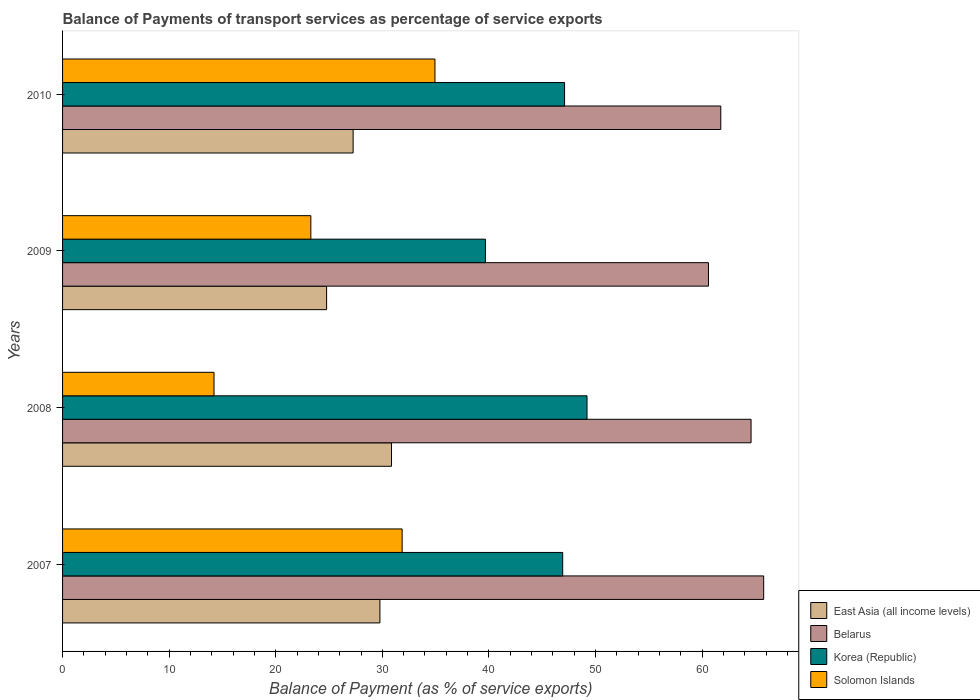How many different coloured bars are there?
Offer a terse response. 4. Are the number of bars per tick equal to the number of legend labels?
Offer a terse response. Yes. Are the number of bars on each tick of the Y-axis equal?
Ensure brevity in your answer.  Yes. How many bars are there on the 2nd tick from the top?
Keep it short and to the point. 4. In how many cases, is the number of bars for a given year not equal to the number of legend labels?
Keep it short and to the point. 0. What is the balance of payments of transport services in East Asia (all income levels) in 2009?
Your answer should be very brief. 24.77. Across all years, what is the maximum balance of payments of transport services in Solomon Islands?
Offer a very short reply. 34.94. Across all years, what is the minimum balance of payments of transport services in Solomon Islands?
Offer a terse response. 14.21. In which year was the balance of payments of transport services in Korea (Republic) maximum?
Keep it short and to the point. 2008. In which year was the balance of payments of transport services in East Asia (all income levels) minimum?
Provide a succinct answer. 2009. What is the total balance of payments of transport services in Korea (Republic) in the graph?
Offer a terse response. 182.9. What is the difference between the balance of payments of transport services in Korea (Republic) in 2007 and that in 2009?
Make the answer very short. 7.25. What is the difference between the balance of payments of transport services in Solomon Islands in 2010 and the balance of payments of transport services in Belarus in 2007?
Offer a terse response. -30.84. What is the average balance of payments of transport services in East Asia (all income levels) per year?
Ensure brevity in your answer.  28.17. In the year 2010, what is the difference between the balance of payments of transport services in East Asia (all income levels) and balance of payments of transport services in Belarus?
Offer a very short reply. -34.49. In how many years, is the balance of payments of transport services in East Asia (all income levels) greater than 16 %?
Ensure brevity in your answer.  4. What is the ratio of the balance of payments of transport services in Korea (Republic) in 2007 to that in 2008?
Provide a succinct answer. 0.95. Is the balance of payments of transport services in Belarus in 2007 less than that in 2009?
Offer a very short reply. No. What is the difference between the highest and the second highest balance of payments of transport services in Belarus?
Provide a short and direct response. 1.18. What is the difference between the highest and the lowest balance of payments of transport services in Belarus?
Make the answer very short. 5.18. In how many years, is the balance of payments of transport services in East Asia (all income levels) greater than the average balance of payments of transport services in East Asia (all income levels) taken over all years?
Give a very brief answer. 2. Is the sum of the balance of payments of transport services in Solomon Islands in 2007 and 2010 greater than the maximum balance of payments of transport services in Korea (Republic) across all years?
Your response must be concise. Yes. Is it the case that in every year, the sum of the balance of payments of transport services in Korea (Republic) and balance of payments of transport services in East Asia (all income levels) is greater than the sum of balance of payments of transport services in Belarus and balance of payments of transport services in Solomon Islands?
Your answer should be very brief. No. What does the 4th bar from the top in 2009 represents?
Ensure brevity in your answer.  East Asia (all income levels). What does the 4th bar from the bottom in 2009 represents?
Your answer should be very brief. Solomon Islands. Is it the case that in every year, the sum of the balance of payments of transport services in Korea (Republic) and balance of payments of transport services in Solomon Islands is greater than the balance of payments of transport services in East Asia (all income levels)?
Ensure brevity in your answer.  Yes. How many bars are there?
Your response must be concise. 16. Are the values on the major ticks of X-axis written in scientific E-notation?
Your answer should be compact. No. Does the graph contain grids?
Ensure brevity in your answer.  No. Where does the legend appear in the graph?
Provide a short and direct response. Bottom right. How are the legend labels stacked?
Provide a short and direct response. Vertical. What is the title of the graph?
Ensure brevity in your answer.  Balance of Payments of transport services as percentage of service exports. Does "Luxembourg" appear as one of the legend labels in the graph?
Provide a short and direct response. No. What is the label or title of the X-axis?
Keep it short and to the point. Balance of Payment (as % of service exports). What is the label or title of the Y-axis?
Offer a terse response. Years. What is the Balance of Payment (as % of service exports) of East Asia (all income levels) in 2007?
Keep it short and to the point. 29.78. What is the Balance of Payment (as % of service exports) of Belarus in 2007?
Provide a succinct answer. 65.78. What is the Balance of Payment (as % of service exports) in Korea (Republic) in 2007?
Your response must be concise. 46.92. What is the Balance of Payment (as % of service exports) in Solomon Islands in 2007?
Offer a terse response. 31.86. What is the Balance of Payment (as % of service exports) of East Asia (all income levels) in 2008?
Provide a succinct answer. 30.86. What is the Balance of Payment (as % of service exports) of Belarus in 2008?
Provide a succinct answer. 64.6. What is the Balance of Payment (as % of service exports) in Korea (Republic) in 2008?
Offer a terse response. 49.21. What is the Balance of Payment (as % of service exports) of Solomon Islands in 2008?
Provide a succinct answer. 14.21. What is the Balance of Payment (as % of service exports) of East Asia (all income levels) in 2009?
Make the answer very short. 24.77. What is the Balance of Payment (as % of service exports) in Belarus in 2009?
Keep it short and to the point. 60.6. What is the Balance of Payment (as % of service exports) of Korea (Republic) in 2009?
Your response must be concise. 39.67. What is the Balance of Payment (as % of service exports) of Solomon Islands in 2009?
Provide a succinct answer. 23.29. What is the Balance of Payment (as % of service exports) in East Asia (all income levels) in 2010?
Make the answer very short. 27.26. What is the Balance of Payment (as % of service exports) of Belarus in 2010?
Offer a very short reply. 61.75. What is the Balance of Payment (as % of service exports) in Korea (Republic) in 2010?
Your response must be concise. 47.1. What is the Balance of Payment (as % of service exports) in Solomon Islands in 2010?
Make the answer very short. 34.94. Across all years, what is the maximum Balance of Payment (as % of service exports) in East Asia (all income levels)?
Offer a terse response. 30.86. Across all years, what is the maximum Balance of Payment (as % of service exports) in Belarus?
Provide a succinct answer. 65.78. Across all years, what is the maximum Balance of Payment (as % of service exports) in Korea (Republic)?
Your answer should be very brief. 49.21. Across all years, what is the maximum Balance of Payment (as % of service exports) of Solomon Islands?
Offer a very short reply. 34.94. Across all years, what is the minimum Balance of Payment (as % of service exports) of East Asia (all income levels)?
Make the answer very short. 24.77. Across all years, what is the minimum Balance of Payment (as % of service exports) of Belarus?
Make the answer very short. 60.6. Across all years, what is the minimum Balance of Payment (as % of service exports) of Korea (Republic)?
Provide a succinct answer. 39.67. Across all years, what is the minimum Balance of Payment (as % of service exports) in Solomon Islands?
Your response must be concise. 14.21. What is the total Balance of Payment (as % of service exports) of East Asia (all income levels) in the graph?
Offer a very short reply. 112.67. What is the total Balance of Payment (as % of service exports) of Belarus in the graph?
Make the answer very short. 252.73. What is the total Balance of Payment (as % of service exports) in Korea (Republic) in the graph?
Ensure brevity in your answer.  182.9. What is the total Balance of Payment (as % of service exports) in Solomon Islands in the graph?
Give a very brief answer. 104.3. What is the difference between the Balance of Payment (as % of service exports) of East Asia (all income levels) in 2007 and that in 2008?
Give a very brief answer. -1.09. What is the difference between the Balance of Payment (as % of service exports) in Belarus in 2007 and that in 2008?
Offer a terse response. 1.18. What is the difference between the Balance of Payment (as % of service exports) in Korea (Republic) in 2007 and that in 2008?
Offer a very short reply. -2.28. What is the difference between the Balance of Payment (as % of service exports) in Solomon Islands in 2007 and that in 2008?
Keep it short and to the point. 17.65. What is the difference between the Balance of Payment (as % of service exports) in East Asia (all income levels) in 2007 and that in 2009?
Offer a very short reply. 5. What is the difference between the Balance of Payment (as % of service exports) of Belarus in 2007 and that in 2009?
Offer a very short reply. 5.18. What is the difference between the Balance of Payment (as % of service exports) in Korea (Republic) in 2007 and that in 2009?
Your answer should be very brief. 7.25. What is the difference between the Balance of Payment (as % of service exports) in Solomon Islands in 2007 and that in 2009?
Your answer should be very brief. 8.57. What is the difference between the Balance of Payment (as % of service exports) of East Asia (all income levels) in 2007 and that in 2010?
Give a very brief answer. 2.51. What is the difference between the Balance of Payment (as % of service exports) of Belarus in 2007 and that in 2010?
Provide a short and direct response. 4.03. What is the difference between the Balance of Payment (as % of service exports) of Korea (Republic) in 2007 and that in 2010?
Give a very brief answer. -0.18. What is the difference between the Balance of Payment (as % of service exports) of Solomon Islands in 2007 and that in 2010?
Your response must be concise. -3.08. What is the difference between the Balance of Payment (as % of service exports) of East Asia (all income levels) in 2008 and that in 2009?
Your response must be concise. 6.09. What is the difference between the Balance of Payment (as % of service exports) in Belarus in 2008 and that in 2009?
Keep it short and to the point. 4. What is the difference between the Balance of Payment (as % of service exports) in Korea (Republic) in 2008 and that in 2009?
Provide a short and direct response. 9.53. What is the difference between the Balance of Payment (as % of service exports) of Solomon Islands in 2008 and that in 2009?
Ensure brevity in your answer.  -9.08. What is the difference between the Balance of Payment (as % of service exports) in East Asia (all income levels) in 2008 and that in 2010?
Give a very brief answer. 3.6. What is the difference between the Balance of Payment (as % of service exports) of Belarus in 2008 and that in 2010?
Give a very brief answer. 2.84. What is the difference between the Balance of Payment (as % of service exports) of Korea (Republic) in 2008 and that in 2010?
Provide a short and direct response. 2.11. What is the difference between the Balance of Payment (as % of service exports) of Solomon Islands in 2008 and that in 2010?
Provide a succinct answer. -20.73. What is the difference between the Balance of Payment (as % of service exports) of East Asia (all income levels) in 2009 and that in 2010?
Provide a succinct answer. -2.49. What is the difference between the Balance of Payment (as % of service exports) in Belarus in 2009 and that in 2010?
Your answer should be compact. -1.16. What is the difference between the Balance of Payment (as % of service exports) in Korea (Republic) in 2009 and that in 2010?
Provide a short and direct response. -7.43. What is the difference between the Balance of Payment (as % of service exports) of Solomon Islands in 2009 and that in 2010?
Ensure brevity in your answer.  -11.64. What is the difference between the Balance of Payment (as % of service exports) in East Asia (all income levels) in 2007 and the Balance of Payment (as % of service exports) in Belarus in 2008?
Keep it short and to the point. -34.82. What is the difference between the Balance of Payment (as % of service exports) of East Asia (all income levels) in 2007 and the Balance of Payment (as % of service exports) of Korea (Republic) in 2008?
Provide a succinct answer. -19.43. What is the difference between the Balance of Payment (as % of service exports) of East Asia (all income levels) in 2007 and the Balance of Payment (as % of service exports) of Solomon Islands in 2008?
Give a very brief answer. 15.56. What is the difference between the Balance of Payment (as % of service exports) in Belarus in 2007 and the Balance of Payment (as % of service exports) in Korea (Republic) in 2008?
Give a very brief answer. 16.57. What is the difference between the Balance of Payment (as % of service exports) in Belarus in 2007 and the Balance of Payment (as % of service exports) in Solomon Islands in 2008?
Keep it short and to the point. 51.57. What is the difference between the Balance of Payment (as % of service exports) of Korea (Republic) in 2007 and the Balance of Payment (as % of service exports) of Solomon Islands in 2008?
Provide a short and direct response. 32.71. What is the difference between the Balance of Payment (as % of service exports) in East Asia (all income levels) in 2007 and the Balance of Payment (as % of service exports) in Belarus in 2009?
Provide a succinct answer. -30.82. What is the difference between the Balance of Payment (as % of service exports) of East Asia (all income levels) in 2007 and the Balance of Payment (as % of service exports) of Korea (Republic) in 2009?
Keep it short and to the point. -9.9. What is the difference between the Balance of Payment (as % of service exports) of East Asia (all income levels) in 2007 and the Balance of Payment (as % of service exports) of Solomon Islands in 2009?
Your response must be concise. 6.48. What is the difference between the Balance of Payment (as % of service exports) in Belarus in 2007 and the Balance of Payment (as % of service exports) in Korea (Republic) in 2009?
Your answer should be compact. 26.11. What is the difference between the Balance of Payment (as % of service exports) in Belarus in 2007 and the Balance of Payment (as % of service exports) in Solomon Islands in 2009?
Make the answer very short. 42.49. What is the difference between the Balance of Payment (as % of service exports) of Korea (Republic) in 2007 and the Balance of Payment (as % of service exports) of Solomon Islands in 2009?
Your answer should be very brief. 23.63. What is the difference between the Balance of Payment (as % of service exports) in East Asia (all income levels) in 2007 and the Balance of Payment (as % of service exports) in Belarus in 2010?
Offer a terse response. -31.98. What is the difference between the Balance of Payment (as % of service exports) in East Asia (all income levels) in 2007 and the Balance of Payment (as % of service exports) in Korea (Republic) in 2010?
Provide a succinct answer. -17.32. What is the difference between the Balance of Payment (as % of service exports) of East Asia (all income levels) in 2007 and the Balance of Payment (as % of service exports) of Solomon Islands in 2010?
Make the answer very short. -5.16. What is the difference between the Balance of Payment (as % of service exports) in Belarus in 2007 and the Balance of Payment (as % of service exports) in Korea (Republic) in 2010?
Provide a succinct answer. 18.68. What is the difference between the Balance of Payment (as % of service exports) in Belarus in 2007 and the Balance of Payment (as % of service exports) in Solomon Islands in 2010?
Offer a very short reply. 30.84. What is the difference between the Balance of Payment (as % of service exports) in Korea (Republic) in 2007 and the Balance of Payment (as % of service exports) in Solomon Islands in 2010?
Give a very brief answer. 11.99. What is the difference between the Balance of Payment (as % of service exports) of East Asia (all income levels) in 2008 and the Balance of Payment (as % of service exports) of Belarus in 2009?
Provide a succinct answer. -29.74. What is the difference between the Balance of Payment (as % of service exports) in East Asia (all income levels) in 2008 and the Balance of Payment (as % of service exports) in Korea (Republic) in 2009?
Offer a very short reply. -8.81. What is the difference between the Balance of Payment (as % of service exports) in East Asia (all income levels) in 2008 and the Balance of Payment (as % of service exports) in Solomon Islands in 2009?
Make the answer very short. 7.57. What is the difference between the Balance of Payment (as % of service exports) in Belarus in 2008 and the Balance of Payment (as % of service exports) in Korea (Republic) in 2009?
Give a very brief answer. 24.92. What is the difference between the Balance of Payment (as % of service exports) of Belarus in 2008 and the Balance of Payment (as % of service exports) of Solomon Islands in 2009?
Make the answer very short. 41.3. What is the difference between the Balance of Payment (as % of service exports) of Korea (Republic) in 2008 and the Balance of Payment (as % of service exports) of Solomon Islands in 2009?
Your response must be concise. 25.91. What is the difference between the Balance of Payment (as % of service exports) in East Asia (all income levels) in 2008 and the Balance of Payment (as % of service exports) in Belarus in 2010?
Your response must be concise. -30.89. What is the difference between the Balance of Payment (as % of service exports) of East Asia (all income levels) in 2008 and the Balance of Payment (as % of service exports) of Korea (Republic) in 2010?
Your answer should be compact. -16.24. What is the difference between the Balance of Payment (as % of service exports) in East Asia (all income levels) in 2008 and the Balance of Payment (as % of service exports) in Solomon Islands in 2010?
Ensure brevity in your answer.  -4.08. What is the difference between the Balance of Payment (as % of service exports) of Belarus in 2008 and the Balance of Payment (as % of service exports) of Korea (Republic) in 2010?
Keep it short and to the point. 17.5. What is the difference between the Balance of Payment (as % of service exports) of Belarus in 2008 and the Balance of Payment (as % of service exports) of Solomon Islands in 2010?
Your answer should be compact. 29.66. What is the difference between the Balance of Payment (as % of service exports) in Korea (Republic) in 2008 and the Balance of Payment (as % of service exports) in Solomon Islands in 2010?
Offer a very short reply. 14.27. What is the difference between the Balance of Payment (as % of service exports) in East Asia (all income levels) in 2009 and the Balance of Payment (as % of service exports) in Belarus in 2010?
Provide a short and direct response. -36.98. What is the difference between the Balance of Payment (as % of service exports) in East Asia (all income levels) in 2009 and the Balance of Payment (as % of service exports) in Korea (Republic) in 2010?
Offer a very short reply. -22.33. What is the difference between the Balance of Payment (as % of service exports) of East Asia (all income levels) in 2009 and the Balance of Payment (as % of service exports) of Solomon Islands in 2010?
Make the answer very short. -10.17. What is the difference between the Balance of Payment (as % of service exports) in Belarus in 2009 and the Balance of Payment (as % of service exports) in Korea (Republic) in 2010?
Keep it short and to the point. 13.5. What is the difference between the Balance of Payment (as % of service exports) of Belarus in 2009 and the Balance of Payment (as % of service exports) of Solomon Islands in 2010?
Provide a short and direct response. 25.66. What is the difference between the Balance of Payment (as % of service exports) of Korea (Republic) in 2009 and the Balance of Payment (as % of service exports) of Solomon Islands in 2010?
Make the answer very short. 4.74. What is the average Balance of Payment (as % of service exports) of East Asia (all income levels) per year?
Ensure brevity in your answer.  28.17. What is the average Balance of Payment (as % of service exports) in Belarus per year?
Ensure brevity in your answer.  63.18. What is the average Balance of Payment (as % of service exports) in Korea (Republic) per year?
Give a very brief answer. 45.73. What is the average Balance of Payment (as % of service exports) of Solomon Islands per year?
Offer a terse response. 26.08. In the year 2007, what is the difference between the Balance of Payment (as % of service exports) of East Asia (all income levels) and Balance of Payment (as % of service exports) of Belarus?
Give a very brief answer. -36. In the year 2007, what is the difference between the Balance of Payment (as % of service exports) in East Asia (all income levels) and Balance of Payment (as % of service exports) in Korea (Republic)?
Ensure brevity in your answer.  -17.15. In the year 2007, what is the difference between the Balance of Payment (as % of service exports) in East Asia (all income levels) and Balance of Payment (as % of service exports) in Solomon Islands?
Keep it short and to the point. -2.08. In the year 2007, what is the difference between the Balance of Payment (as % of service exports) of Belarus and Balance of Payment (as % of service exports) of Korea (Republic)?
Your response must be concise. 18.86. In the year 2007, what is the difference between the Balance of Payment (as % of service exports) in Belarus and Balance of Payment (as % of service exports) in Solomon Islands?
Your answer should be very brief. 33.92. In the year 2007, what is the difference between the Balance of Payment (as % of service exports) of Korea (Republic) and Balance of Payment (as % of service exports) of Solomon Islands?
Provide a succinct answer. 15.06. In the year 2008, what is the difference between the Balance of Payment (as % of service exports) in East Asia (all income levels) and Balance of Payment (as % of service exports) in Belarus?
Offer a terse response. -33.73. In the year 2008, what is the difference between the Balance of Payment (as % of service exports) of East Asia (all income levels) and Balance of Payment (as % of service exports) of Korea (Republic)?
Offer a very short reply. -18.34. In the year 2008, what is the difference between the Balance of Payment (as % of service exports) of East Asia (all income levels) and Balance of Payment (as % of service exports) of Solomon Islands?
Make the answer very short. 16.65. In the year 2008, what is the difference between the Balance of Payment (as % of service exports) in Belarus and Balance of Payment (as % of service exports) in Korea (Republic)?
Ensure brevity in your answer.  15.39. In the year 2008, what is the difference between the Balance of Payment (as % of service exports) of Belarus and Balance of Payment (as % of service exports) of Solomon Islands?
Keep it short and to the point. 50.38. In the year 2008, what is the difference between the Balance of Payment (as % of service exports) of Korea (Republic) and Balance of Payment (as % of service exports) of Solomon Islands?
Make the answer very short. 35. In the year 2009, what is the difference between the Balance of Payment (as % of service exports) of East Asia (all income levels) and Balance of Payment (as % of service exports) of Belarus?
Offer a very short reply. -35.83. In the year 2009, what is the difference between the Balance of Payment (as % of service exports) in East Asia (all income levels) and Balance of Payment (as % of service exports) in Korea (Republic)?
Provide a succinct answer. -14.9. In the year 2009, what is the difference between the Balance of Payment (as % of service exports) in East Asia (all income levels) and Balance of Payment (as % of service exports) in Solomon Islands?
Provide a succinct answer. 1.48. In the year 2009, what is the difference between the Balance of Payment (as % of service exports) of Belarus and Balance of Payment (as % of service exports) of Korea (Republic)?
Provide a succinct answer. 20.93. In the year 2009, what is the difference between the Balance of Payment (as % of service exports) of Belarus and Balance of Payment (as % of service exports) of Solomon Islands?
Ensure brevity in your answer.  37.3. In the year 2009, what is the difference between the Balance of Payment (as % of service exports) of Korea (Republic) and Balance of Payment (as % of service exports) of Solomon Islands?
Provide a short and direct response. 16.38. In the year 2010, what is the difference between the Balance of Payment (as % of service exports) of East Asia (all income levels) and Balance of Payment (as % of service exports) of Belarus?
Your answer should be very brief. -34.49. In the year 2010, what is the difference between the Balance of Payment (as % of service exports) in East Asia (all income levels) and Balance of Payment (as % of service exports) in Korea (Republic)?
Your answer should be compact. -19.84. In the year 2010, what is the difference between the Balance of Payment (as % of service exports) of East Asia (all income levels) and Balance of Payment (as % of service exports) of Solomon Islands?
Your answer should be very brief. -7.68. In the year 2010, what is the difference between the Balance of Payment (as % of service exports) of Belarus and Balance of Payment (as % of service exports) of Korea (Republic)?
Keep it short and to the point. 14.65. In the year 2010, what is the difference between the Balance of Payment (as % of service exports) of Belarus and Balance of Payment (as % of service exports) of Solomon Islands?
Make the answer very short. 26.82. In the year 2010, what is the difference between the Balance of Payment (as % of service exports) in Korea (Republic) and Balance of Payment (as % of service exports) in Solomon Islands?
Offer a very short reply. 12.16. What is the ratio of the Balance of Payment (as % of service exports) in East Asia (all income levels) in 2007 to that in 2008?
Ensure brevity in your answer.  0.96. What is the ratio of the Balance of Payment (as % of service exports) of Belarus in 2007 to that in 2008?
Ensure brevity in your answer.  1.02. What is the ratio of the Balance of Payment (as % of service exports) of Korea (Republic) in 2007 to that in 2008?
Your response must be concise. 0.95. What is the ratio of the Balance of Payment (as % of service exports) of Solomon Islands in 2007 to that in 2008?
Provide a succinct answer. 2.24. What is the ratio of the Balance of Payment (as % of service exports) of East Asia (all income levels) in 2007 to that in 2009?
Your answer should be compact. 1.2. What is the ratio of the Balance of Payment (as % of service exports) of Belarus in 2007 to that in 2009?
Provide a short and direct response. 1.09. What is the ratio of the Balance of Payment (as % of service exports) of Korea (Republic) in 2007 to that in 2009?
Ensure brevity in your answer.  1.18. What is the ratio of the Balance of Payment (as % of service exports) in Solomon Islands in 2007 to that in 2009?
Your response must be concise. 1.37. What is the ratio of the Balance of Payment (as % of service exports) of East Asia (all income levels) in 2007 to that in 2010?
Keep it short and to the point. 1.09. What is the ratio of the Balance of Payment (as % of service exports) in Belarus in 2007 to that in 2010?
Offer a terse response. 1.07. What is the ratio of the Balance of Payment (as % of service exports) of Solomon Islands in 2007 to that in 2010?
Give a very brief answer. 0.91. What is the ratio of the Balance of Payment (as % of service exports) in East Asia (all income levels) in 2008 to that in 2009?
Your answer should be compact. 1.25. What is the ratio of the Balance of Payment (as % of service exports) of Belarus in 2008 to that in 2009?
Your answer should be very brief. 1.07. What is the ratio of the Balance of Payment (as % of service exports) of Korea (Republic) in 2008 to that in 2009?
Offer a terse response. 1.24. What is the ratio of the Balance of Payment (as % of service exports) in Solomon Islands in 2008 to that in 2009?
Provide a succinct answer. 0.61. What is the ratio of the Balance of Payment (as % of service exports) in East Asia (all income levels) in 2008 to that in 2010?
Your answer should be very brief. 1.13. What is the ratio of the Balance of Payment (as % of service exports) in Belarus in 2008 to that in 2010?
Offer a very short reply. 1.05. What is the ratio of the Balance of Payment (as % of service exports) of Korea (Republic) in 2008 to that in 2010?
Provide a succinct answer. 1.04. What is the ratio of the Balance of Payment (as % of service exports) of Solomon Islands in 2008 to that in 2010?
Make the answer very short. 0.41. What is the ratio of the Balance of Payment (as % of service exports) of East Asia (all income levels) in 2009 to that in 2010?
Offer a terse response. 0.91. What is the ratio of the Balance of Payment (as % of service exports) in Belarus in 2009 to that in 2010?
Make the answer very short. 0.98. What is the ratio of the Balance of Payment (as % of service exports) of Korea (Republic) in 2009 to that in 2010?
Provide a succinct answer. 0.84. What is the ratio of the Balance of Payment (as % of service exports) of Solomon Islands in 2009 to that in 2010?
Provide a succinct answer. 0.67. What is the difference between the highest and the second highest Balance of Payment (as % of service exports) in East Asia (all income levels)?
Your response must be concise. 1.09. What is the difference between the highest and the second highest Balance of Payment (as % of service exports) in Belarus?
Provide a succinct answer. 1.18. What is the difference between the highest and the second highest Balance of Payment (as % of service exports) of Korea (Republic)?
Offer a terse response. 2.11. What is the difference between the highest and the second highest Balance of Payment (as % of service exports) in Solomon Islands?
Your response must be concise. 3.08. What is the difference between the highest and the lowest Balance of Payment (as % of service exports) of East Asia (all income levels)?
Your answer should be very brief. 6.09. What is the difference between the highest and the lowest Balance of Payment (as % of service exports) of Belarus?
Your answer should be very brief. 5.18. What is the difference between the highest and the lowest Balance of Payment (as % of service exports) in Korea (Republic)?
Your answer should be very brief. 9.53. What is the difference between the highest and the lowest Balance of Payment (as % of service exports) in Solomon Islands?
Ensure brevity in your answer.  20.73. 